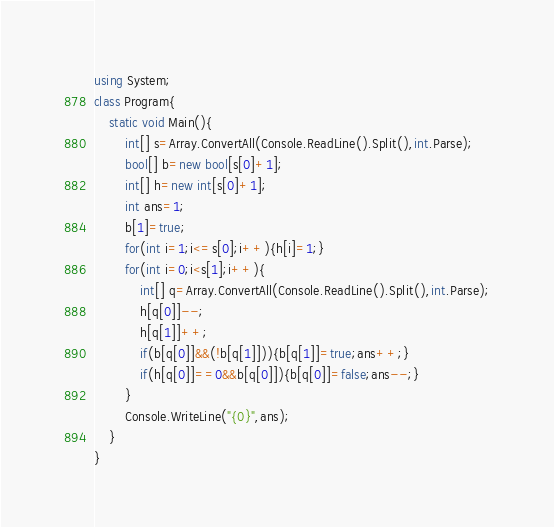<code> <loc_0><loc_0><loc_500><loc_500><_C#_>using System;
class Program{
	static void Main(){
		int[] s=Array.ConvertAll(Console.ReadLine().Split(),int.Parse);
		bool[] b=new bool[s[0]+1];
		int[] h=new int[s[0]+1];
		int ans=1;
		b[1]=true;
		for(int i=1;i<=s[0];i++){h[i]=1;}
		for(int i=0;i<s[1];i++){
			int[] q=Array.ConvertAll(Console.ReadLine().Split(),int.Parse);
			h[q[0]]--;
			h[q[1]]++;
			if(b[q[0]]&&(!b[q[1]])){b[q[1]]=true;ans++;}
			if(h[q[0]]==0&&b[q[0]]){b[q[0]]=false;ans--;}
		}
		Console.WriteLine("{0}",ans);
	}
}</code> 